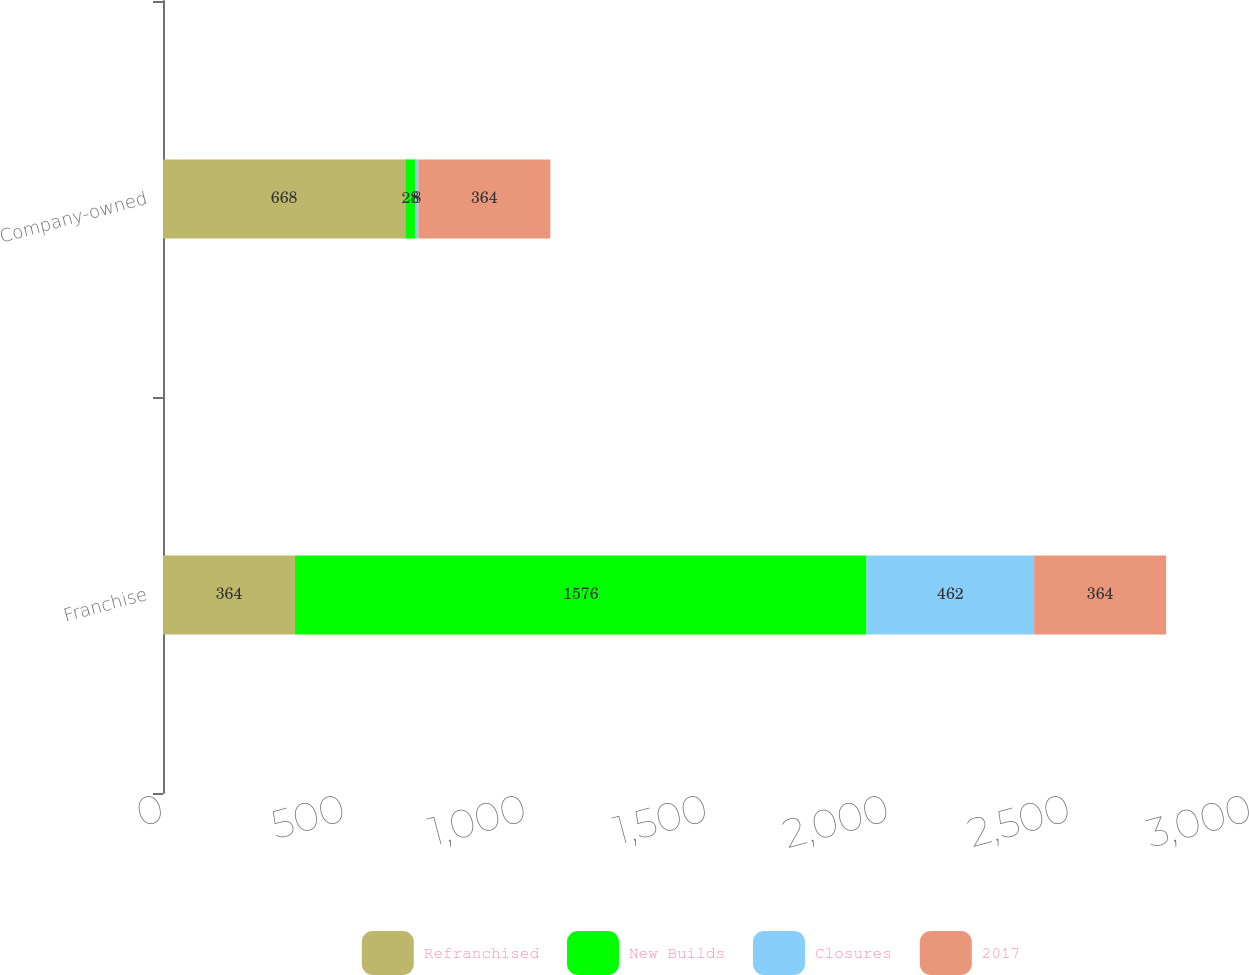<chart> <loc_0><loc_0><loc_500><loc_500><stacked_bar_chart><ecel><fcel>Franchise<fcel>Company-owned<nl><fcel>Refranchised<fcel>364<fcel>668<nl><fcel>New Builds<fcel>1576<fcel>28<nl><fcel>Closures<fcel>462<fcel>8<nl><fcel>2017<fcel>364<fcel>364<nl></chart> 